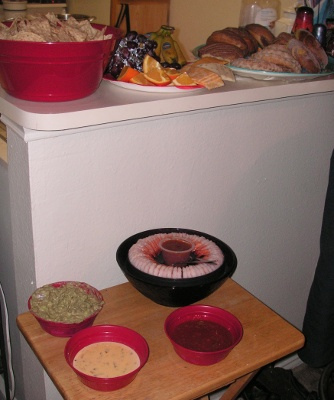<image>
Is there a plate behind the table? Yes. From this viewpoint, the plate is positioned behind the table, with the table partially or fully occluding the plate. 